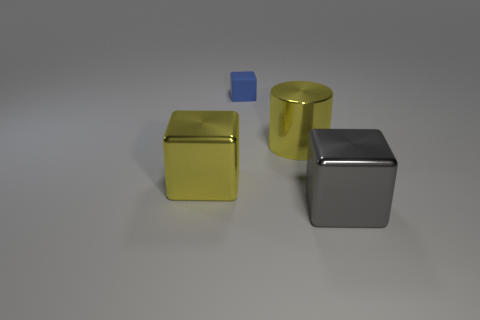Add 3 cubes. How many objects exist? 7 Subtract all cubes. How many objects are left? 1 Add 1 large gray cubes. How many large gray cubes exist? 2 Subtract 0 yellow balls. How many objects are left? 4 Subtract all brown objects. Subtract all rubber cubes. How many objects are left? 3 Add 2 small blue matte cubes. How many small blue matte cubes are left? 3 